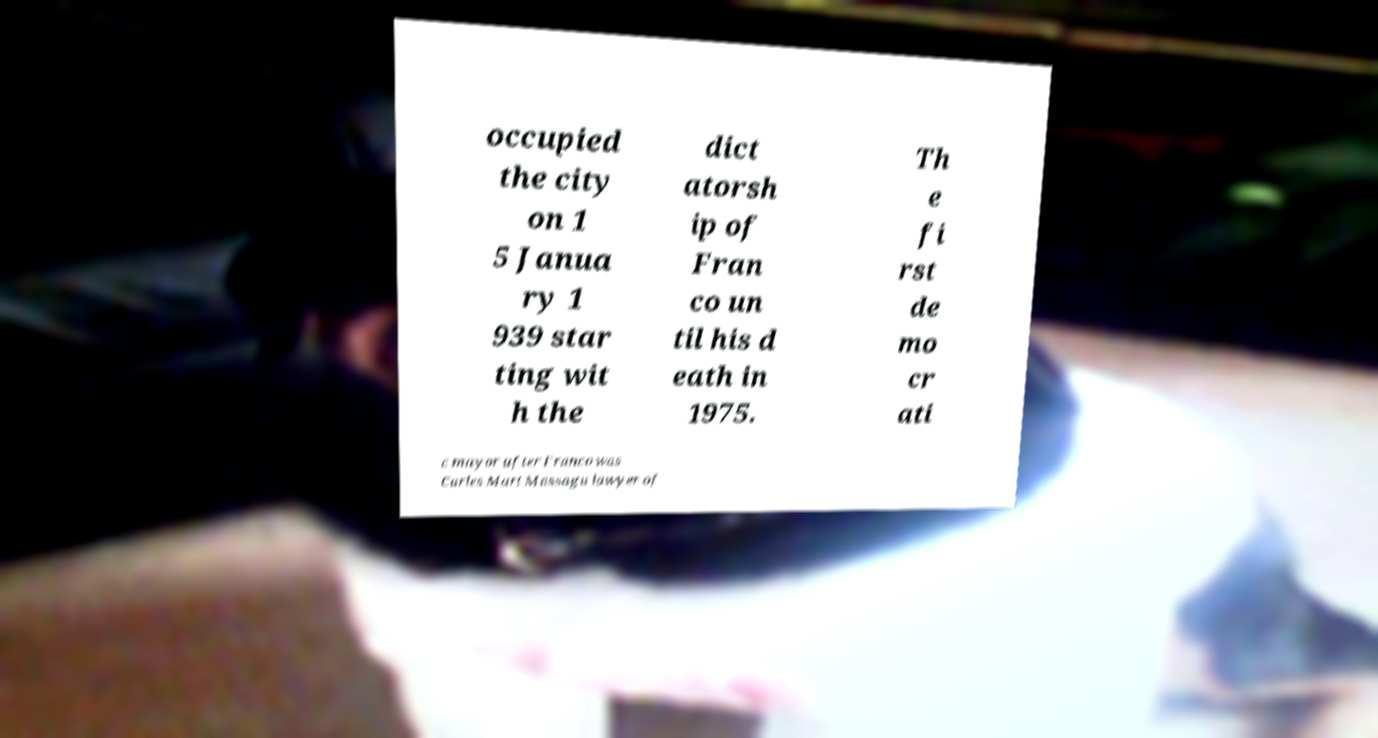Could you extract and type out the text from this image? occupied the city on 1 5 Janua ry 1 939 star ting wit h the dict atorsh ip of Fran co un til his d eath in 1975. Th e fi rst de mo cr ati c mayor after Franco was Carles Mart Massagu lawyer of 